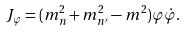Convert formula to latex. <formula><loc_0><loc_0><loc_500><loc_500>J _ { \varphi } = ( m _ { n } ^ { 2 } + m _ { n ^ { \prime } } ^ { 2 } - m ^ { 2 } ) \varphi \dot { \varphi } .</formula> 